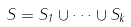Convert formula to latex. <formula><loc_0><loc_0><loc_500><loc_500>S = S _ { 1 } \cup \cdots \cup S _ { k }</formula> 